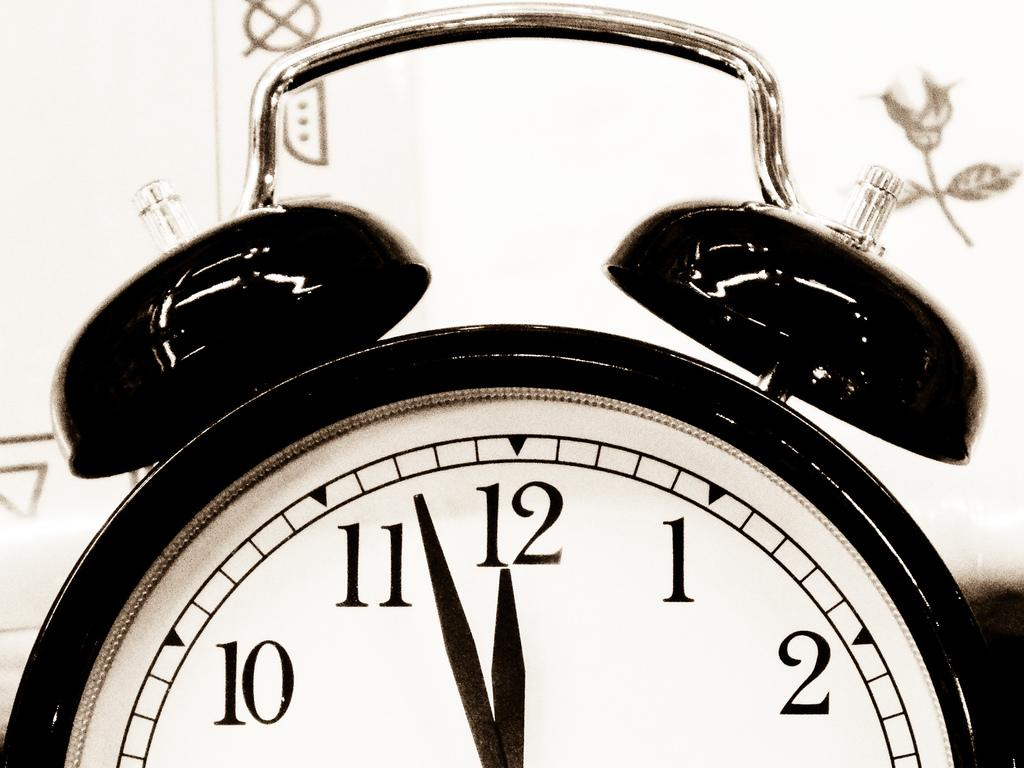<image>
Offer a succinct explanation of the picture presented. An old fashion alarm clock with a white face and black body reads 3 minutes to 12. 